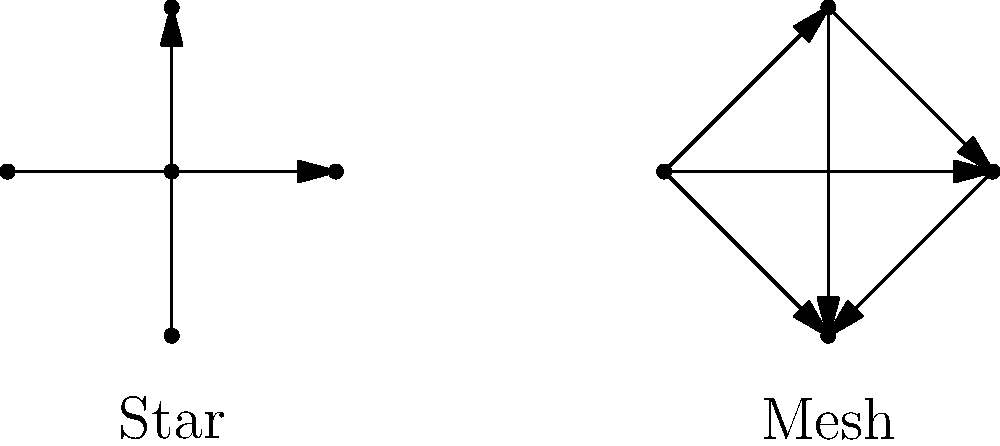Hey Justin, remember when we used to discuss network topologies during our team projects? I've been thinking about the differences between star and mesh configurations. In a network with 5 nodes, how many connections would be required for a full mesh topology compared to a star topology? Let's break this down step-by-step:

1. Star Topology:
   - In a star topology, all nodes connect to a central hub.
   - With 5 nodes, we need 4 connections to the central hub.
   - Total connections in star topology = 4

2. Mesh Topology:
   - In a full mesh topology, every node connects to every other node.
   - To calculate the number of connections, we use the formula:
     $n(n-1)/2$, where $n$ is the number of nodes.
   - With 5 nodes: $5(5-1)/2 = 5 * 4 / 2 = 10$
   - Total connections in mesh topology = 10

3. Comparison:
   - Mesh topology requires 10 connections
   - Star topology requires 4 connections
   - Difference: $10 - 4 = 6$

Therefore, a full mesh topology with 5 nodes requires 6 more connections than a star topology with the same number of nodes.
Answer: 6 more connections 